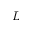<formula> <loc_0><loc_0><loc_500><loc_500>L</formula> 